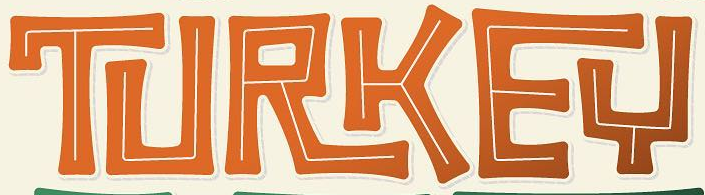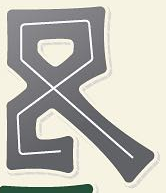What text appears in these images from left to right, separated by a semicolon? TURKEY; & 